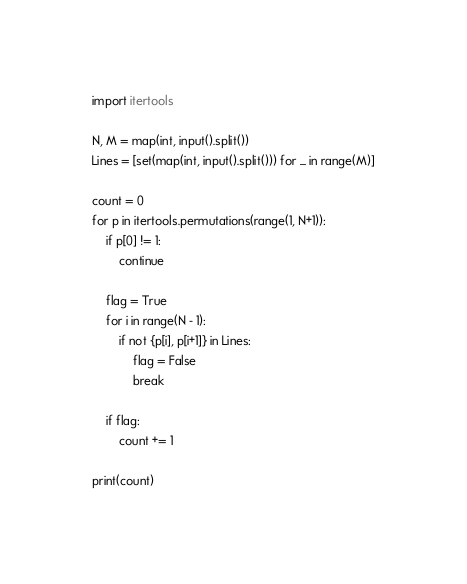Convert code to text. <code><loc_0><loc_0><loc_500><loc_500><_Python_>import itertools

N, M = map(int, input().split())
Lines = [set(map(int, input().split())) for _ in range(M)]

count = 0
for p in itertools.permutations(range(1, N+1)):
    if p[0] != 1:
        continue

    flag = True
    for i in range(N - 1):
        if not {p[i], p[i+1]} in Lines:
            flag = False
            break

    if flag:
        count += 1

print(count)</code> 